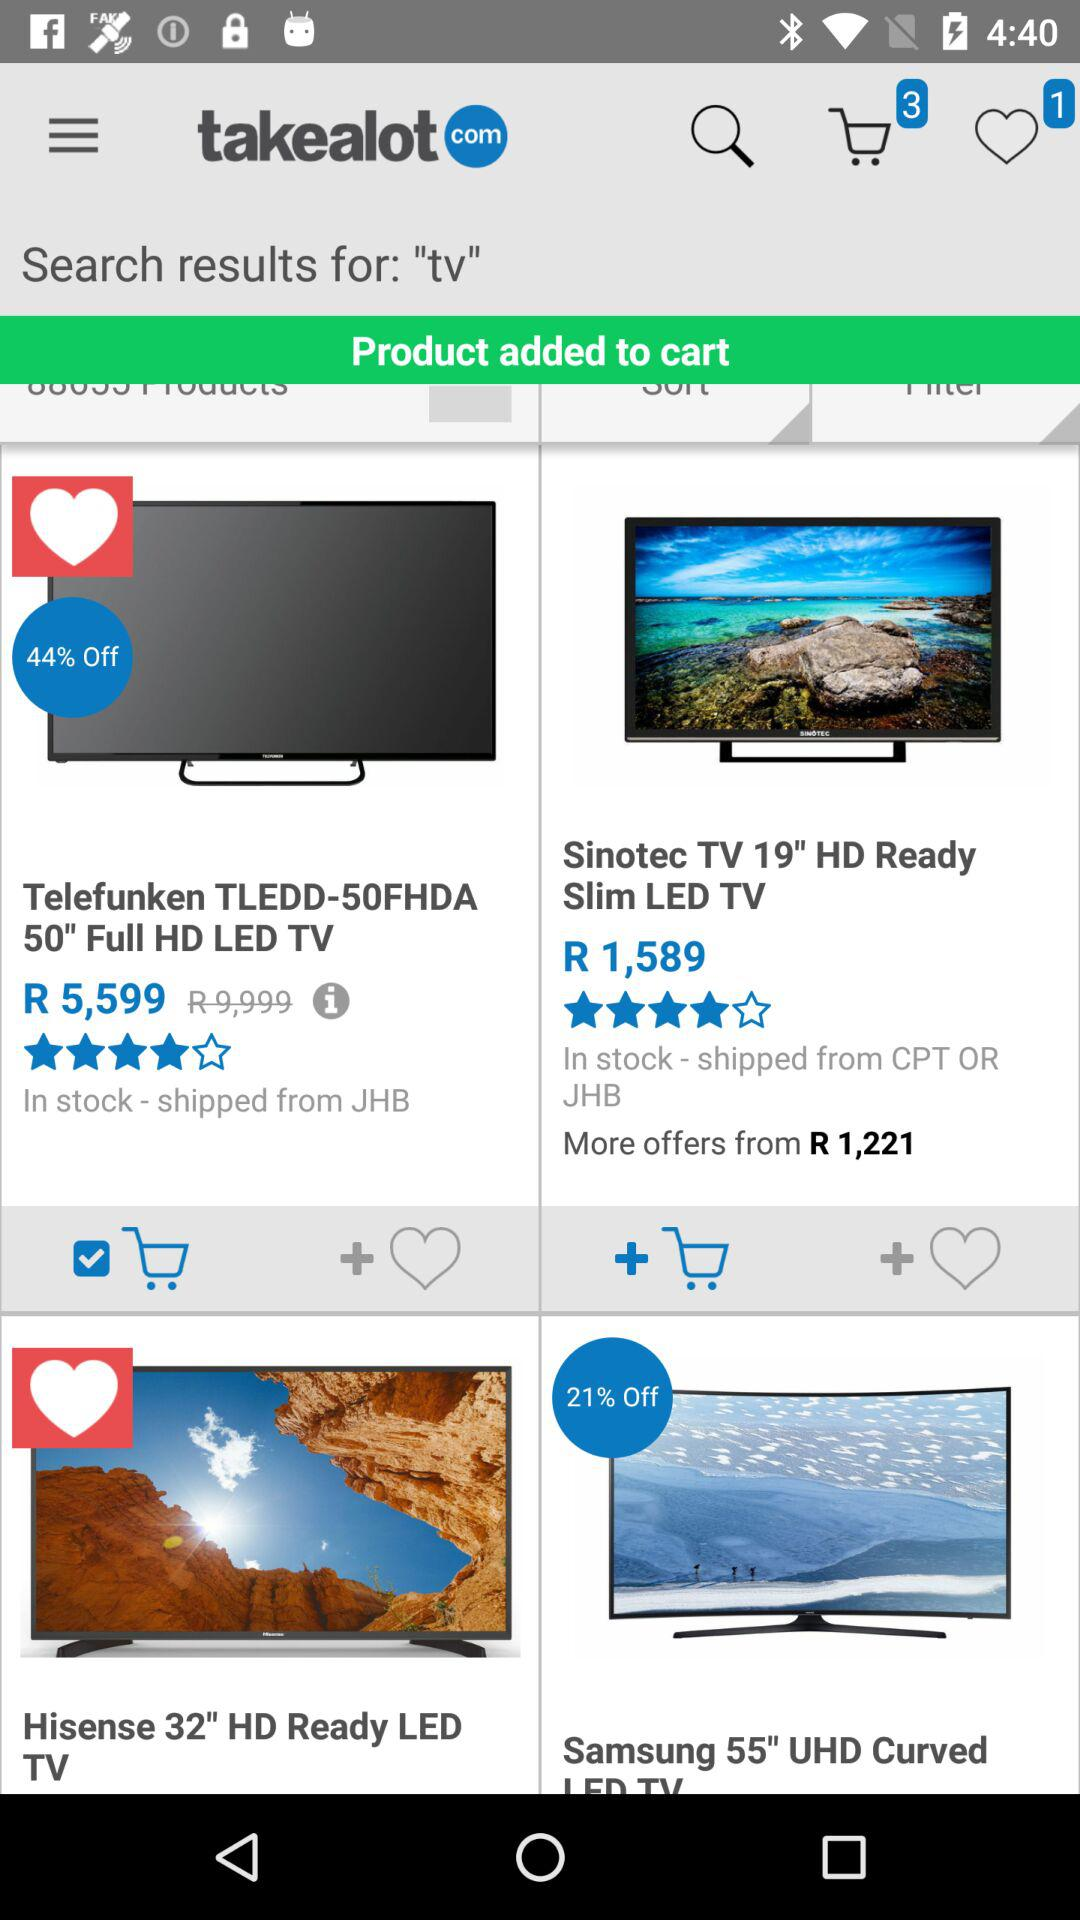How many items are in the cart?
Answer the question using a single word or phrase. 3 